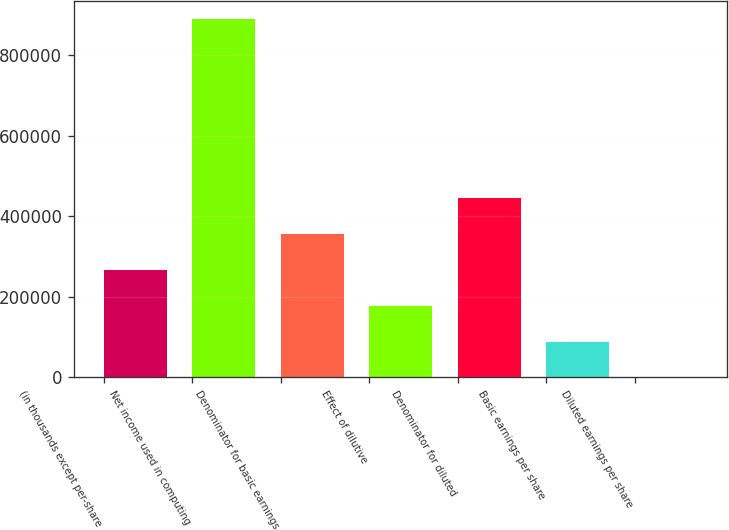Convert chart to OTSL. <chart><loc_0><loc_0><loc_500><loc_500><bar_chart><fcel>(in thousands except per-share<fcel>Net income used in computing<fcel>Denominator for basic earnings<fcel>Effect of dilutive<fcel>Denominator for diluted<fcel>Basic earnings per share<fcel>Diluted earnings per share<nl><fcel>266932<fcel>889766<fcel>355908<fcel>177956<fcel>444884<fcel>88979.3<fcel>3<nl></chart> 